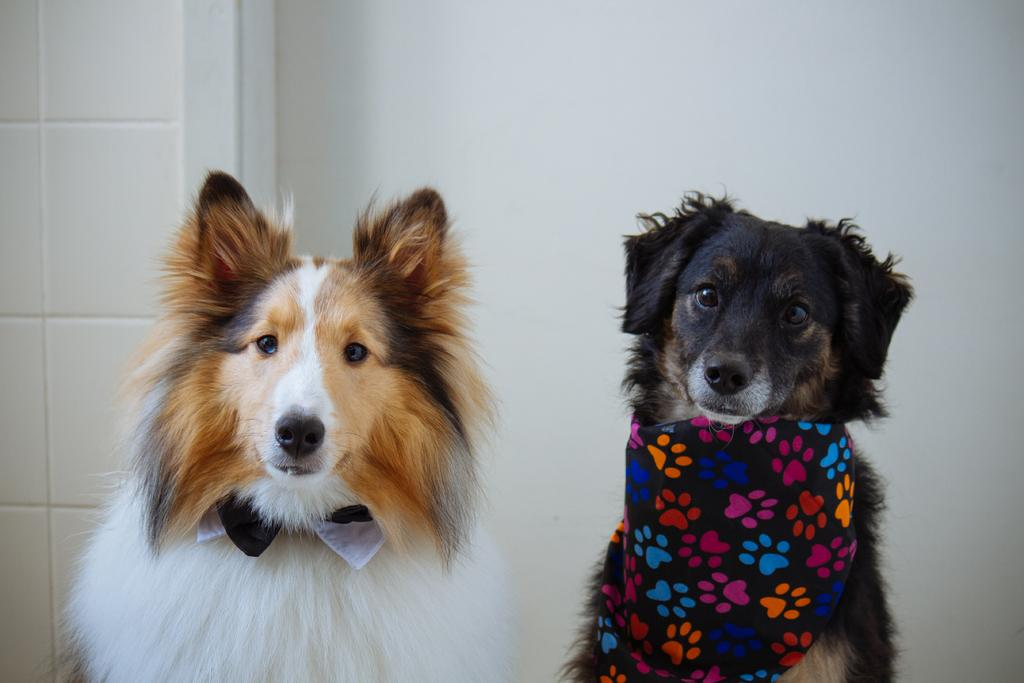How many dogs are present in the image? There are two dogs in the image. What are the dogs doing in the image? The dogs are looking at a picture. What can be seen in the background of the image? There is a wall in the background of the image. What type of locket is hanging from the wall in the image? There is no locket present in the image; it only features two dogs looking at a picture and a wall in the background. 